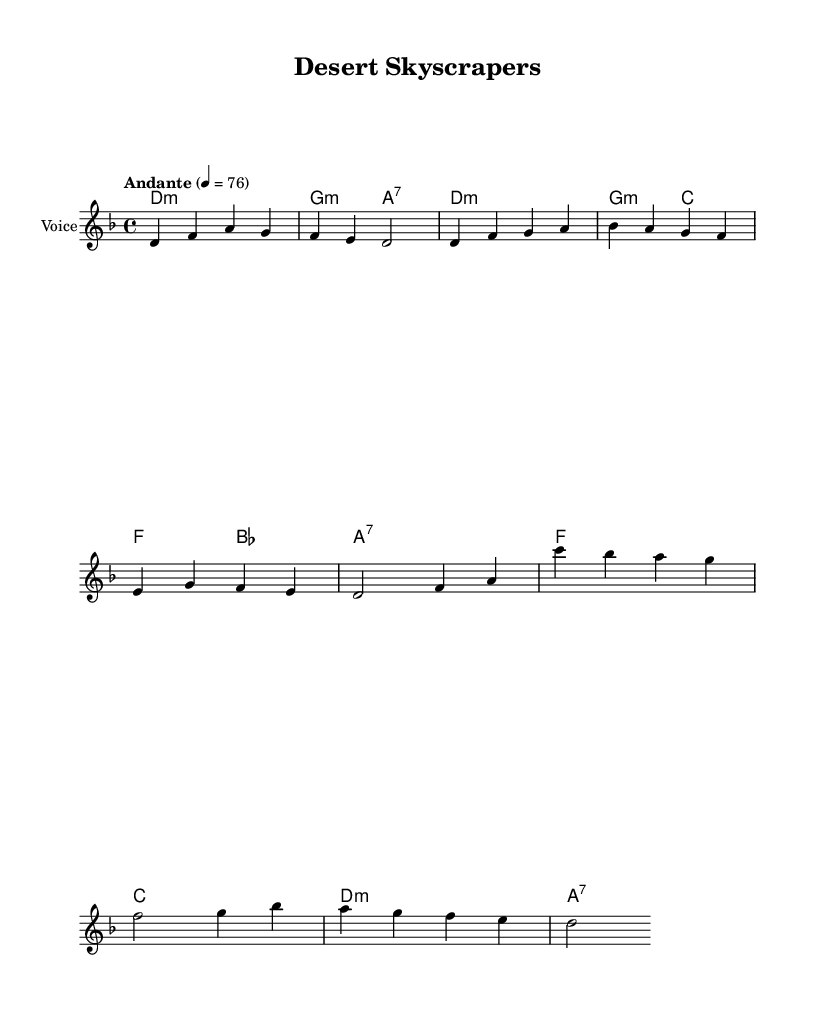What is the key signature of this music? The key signature is D minor, which is indicated by one flat (B flat) on the staff.
Answer: D minor What is the time signature of this music? The time signature is 4/4, which means there are four beats in each measure. This is shown at the beginning of the score.
Answer: 4/4 What is the tempo marking for this piece? The tempo marking is "Andante", which is indicated above the staff with a metronome mark of 76.
Answer: Andante How many measures are in the melody? The melody contains a total of eight measures as indicated by the vertical bar lines separating each measure.
Answer: Eight measures What is the first chord in the harmony? The first chord is D minor, which is shown as "d1:m" in the chord names section.
Answer: D minor In which section do traditional themes appear in the lyrics? Traditional themes appear in the verse section, as it discusses the coexistence of tradition and progress.
Answer: Verse What overall theme does this folk music address? The overall theme addresses societal changes and urban development, especially the contrast between tradition and modernity.
Answer: Societal changes 